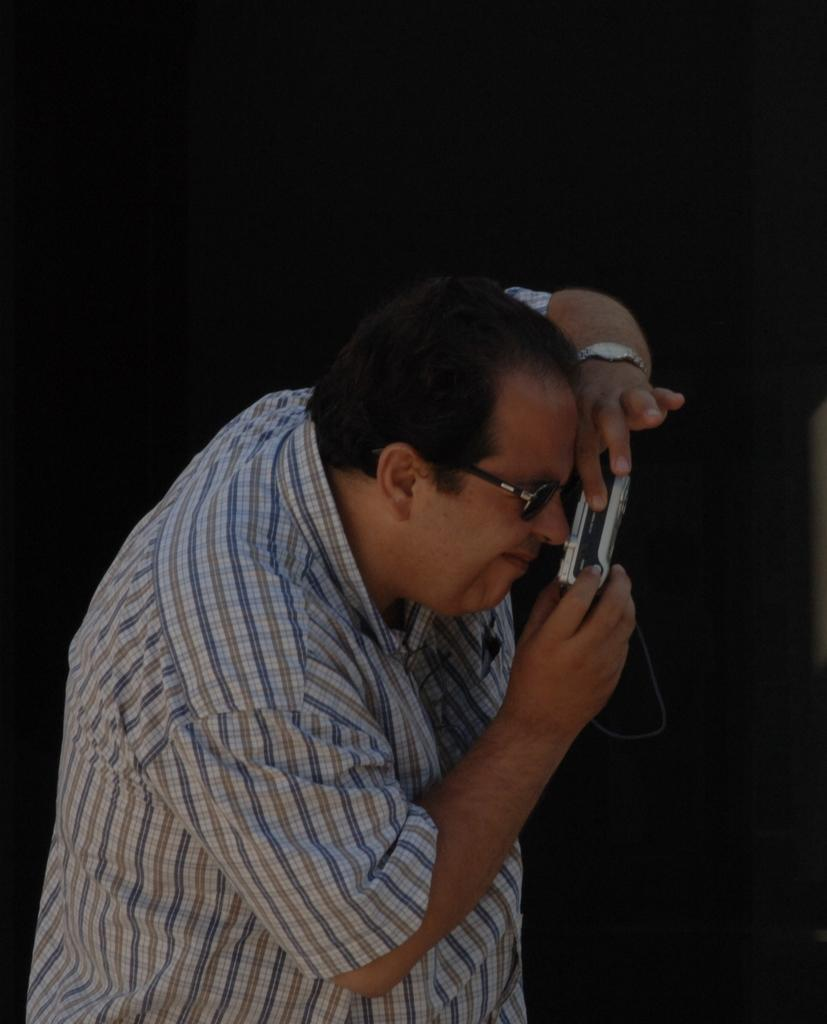What can be seen in the image? There is a person in the image. What is the person wearing? The person is wearing a white shirt. What is the person holding in the image? The person is holding a camera. How would you describe the background of the image? The background of the image is dark. Where is the drawer located in the image? There is no drawer present in the image. How many birds are in the flock in the image? There is no flock of birds present in the image. 